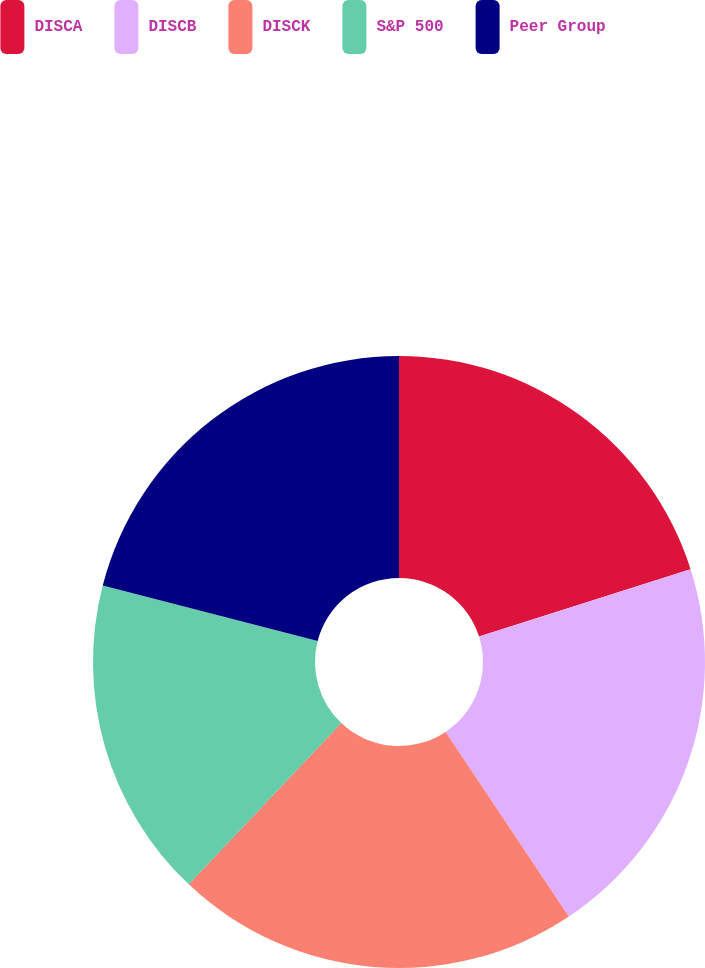Convert chart to OTSL. <chart><loc_0><loc_0><loc_500><loc_500><pie_chart><fcel>DISCA<fcel>DISCB<fcel>DISCK<fcel>S&P 500<fcel>Peer Group<nl><fcel>20.1%<fcel>20.54%<fcel>21.42%<fcel>16.97%<fcel>20.98%<nl></chart> 